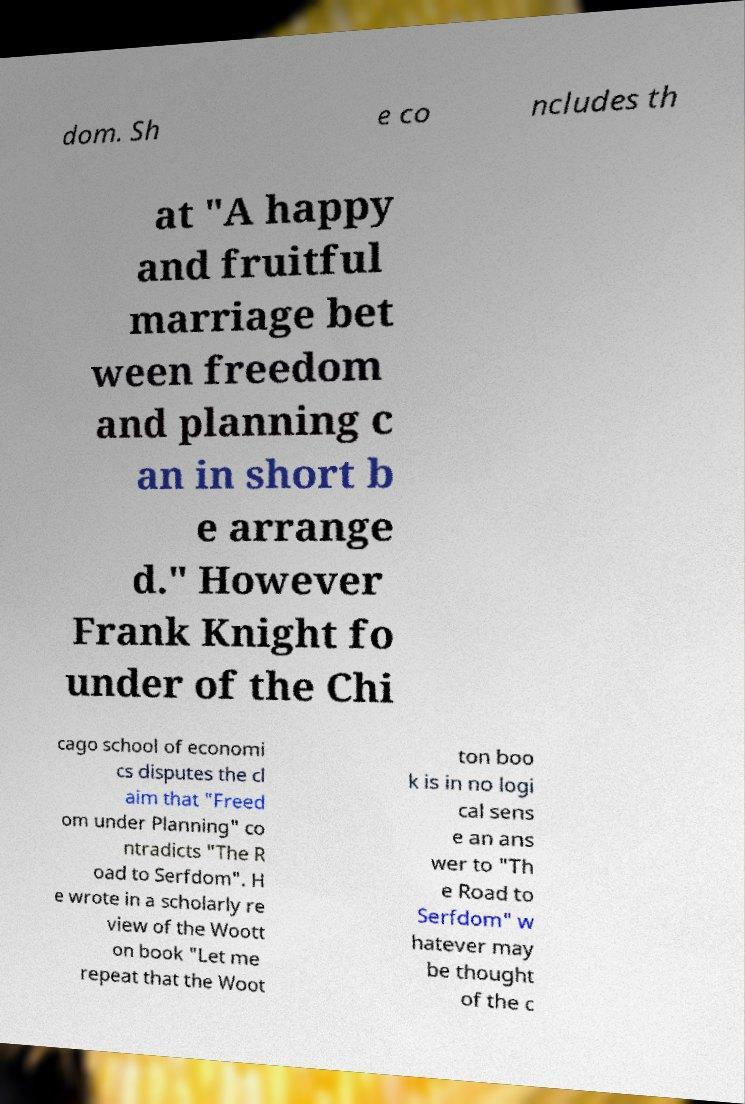Could you extract and type out the text from this image? dom. Sh e co ncludes th at "A happy and fruitful marriage bet ween freedom and planning c an in short b e arrange d." However Frank Knight fo under of the Chi cago school of economi cs disputes the cl aim that "Freed om under Planning" co ntradicts "The R oad to Serfdom". H e wrote in a scholarly re view of the Woott on book "Let me repeat that the Woot ton boo k is in no logi cal sens e an ans wer to "Th e Road to Serfdom" w hatever may be thought of the c 